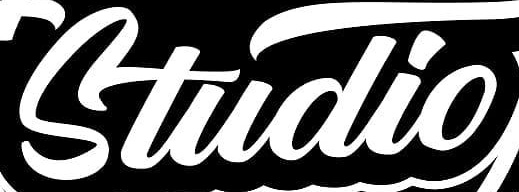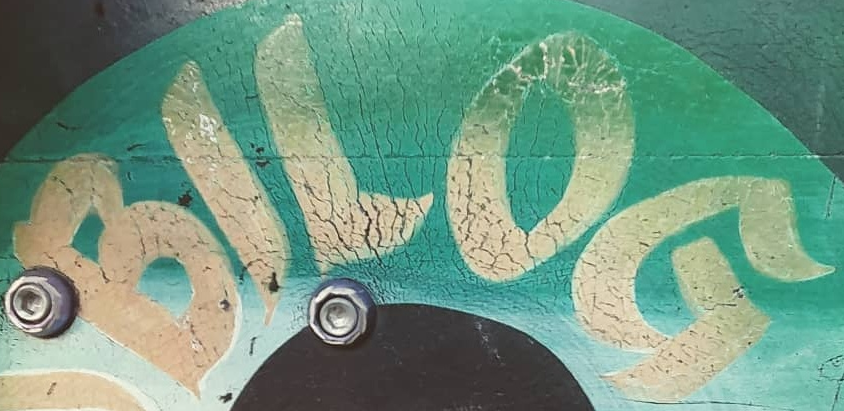Identify the words shown in these images in order, separated by a semicolon. Studio; BILOG 